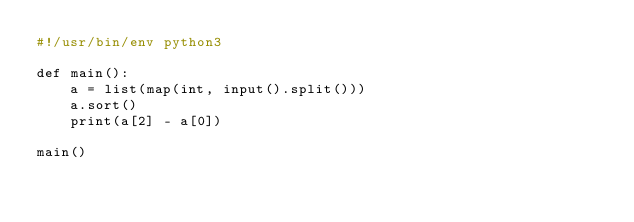<code> <loc_0><loc_0><loc_500><loc_500><_Python_>#!/usr/bin/env python3

def main():
    a = list(map(int, input().split()))
    a.sort()
    print(a[2] - a[0])

main()
</code> 